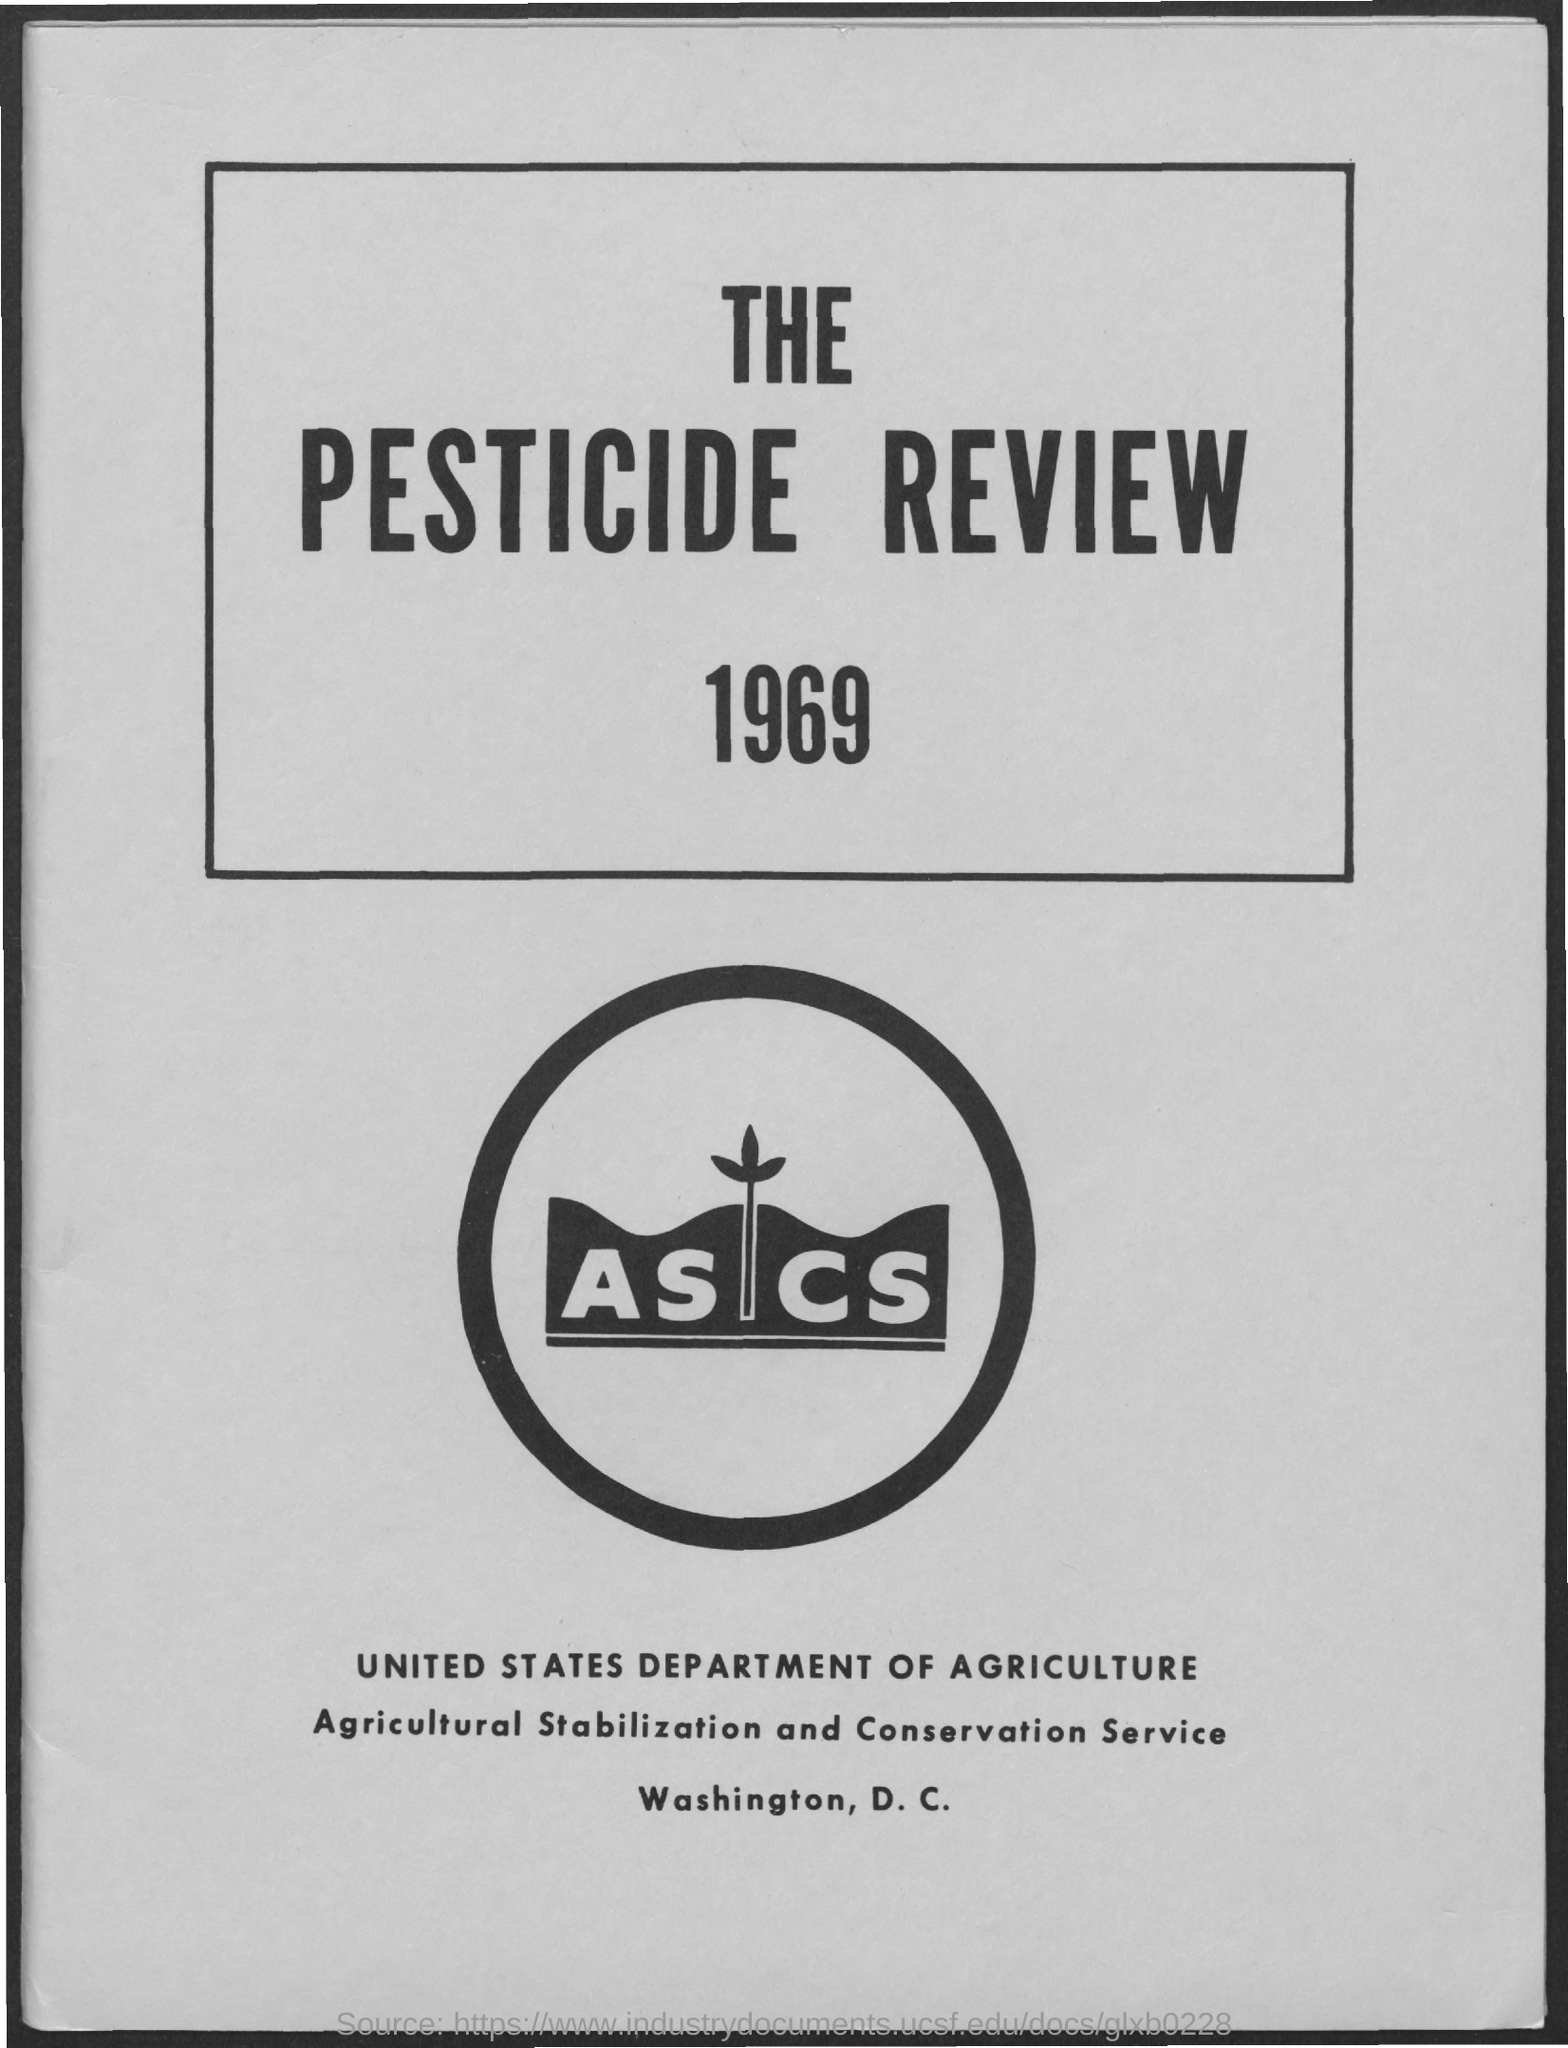Highlight a few significant elements in this photo. The United States Department of Agriculture is the name of a department. 